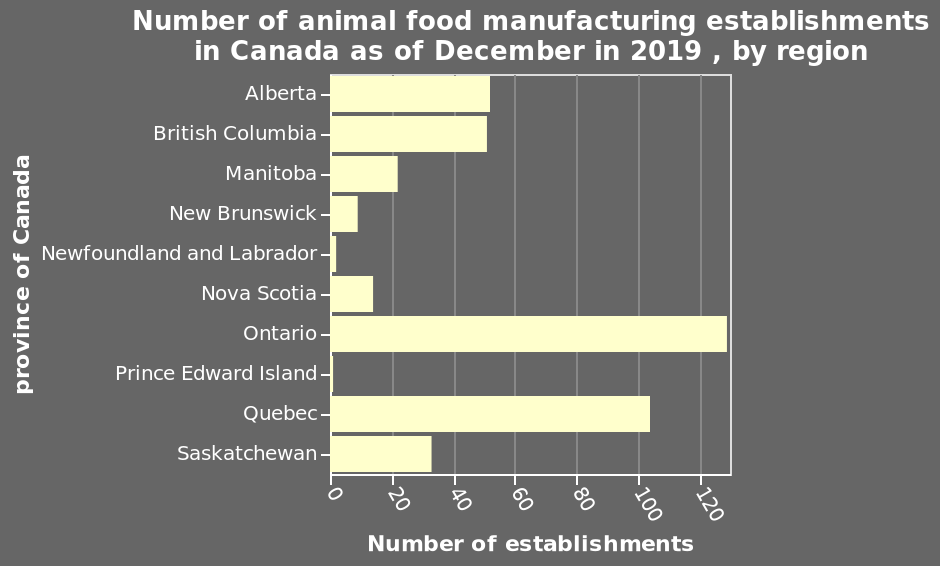<image>
What does the bar chart display? The bar chart displays the number of animal food manufacturing establishments in Canada as of December 2019, categorized by region. How many establishments does Ontario have? Nearly 130 Which province comes in second in terms of the number of establishments?  Quebec What is the range of the linear scale on the x-axis? The linear scale on the x-axis ranges from 0 to 120, representing the number of establishments. 